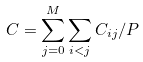<formula> <loc_0><loc_0><loc_500><loc_500>C = \sum _ { j = 0 } ^ { M } \sum _ { i < j } C _ { i j } / P</formula> 